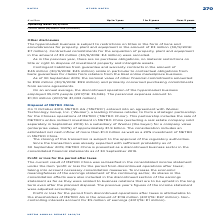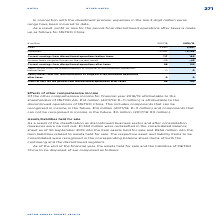According to Metro Ag's financial document, What was done to increase the economic meaningfulness of the earnings statement of the continuing sector? its shares in the consolidation effects were also included in the discontinued section of the earnings statement as far as they were related to business relations that are to be upheld in the long term even after the planned disposal.. The document states: "f the earnings statement of the continuing sector, its shares in the consolidation effects were also included in the discontinued section of the earni..." Also, How much of earnings does the Noncontrolling interests account for in FY2019? According to the financial document, €5 million. The relevant text states: "controlling interests account for €5 million of earnings (2017/18: €1 million)...." Also, What were the components factored in during the calculation of Current earnings from discontinued operations before taxes? The document shows two values: Sales and Expenses. From the document: "Expenses −2,563 −2,736 Sales 2,680 2,901..." Additionally, In which year was Current earnings from discontinued operations after taxes larger? According to the financial document, 2019. The relevant text states: "Operating leases 30/9/2019..." Also, can you calculate: What was the change in Sales in FY2019 from FY2018? Based on the calculation: 2,901-2,680, the result is 221 (in millions). This is based on the information: "Sales 2,680 2,901 Sales 2,680 2,901..." The key data points involved are: 2,680, 2,901. Also, can you calculate: What was the percentage change in Sales in FY2019 from FY2018? To answer this question, I need to perform calculations using the financial data. The calculation is: (2,901-2,680)/2,680, which equals 8.25 (percentage). This is based on the information: "Sales 2,680 2,901 Sales 2,680 2,901..." The key data points involved are: 2,680, 2,901. 